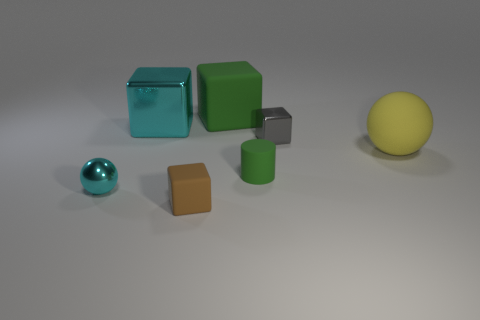Is there anything else that is the same size as the cylinder?
Keep it short and to the point. Yes. What material is the ball that is to the left of the tiny rubber object in front of the rubber cylinder made of?
Your answer should be compact. Metal. Are there the same number of large cyan objects left of the tiny sphere and green objects that are on the right side of the tiny green cylinder?
Offer a very short reply. Yes. What number of objects are either small blocks that are in front of the metallic sphere or big green objects that are to the left of the matte cylinder?
Your answer should be compact. 2. There is a small thing that is on the right side of the green block and in front of the large yellow ball; what is its material?
Your answer should be compact. Rubber. There is a metallic object that is on the right side of the small block that is in front of the green matte object in front of the big green rubber cube; what size is it?
Offer a very short reply. Small. Are there more small cyan metal things than tiny yellow things?
Give a very brief answer. Yes. Do the object right of the small gray thing and the small green cylinder have the same material?
Your answer should be very brief. Yes. Is the number of large green rubber things less than the number of metal objects?
Provide a short and direct response. Yes. There is a sphere left of the brown matte thing on the left side of the green rubber cylinder; are there any tiny shiny spheres behind it?
Your answer should be very brief. No. 